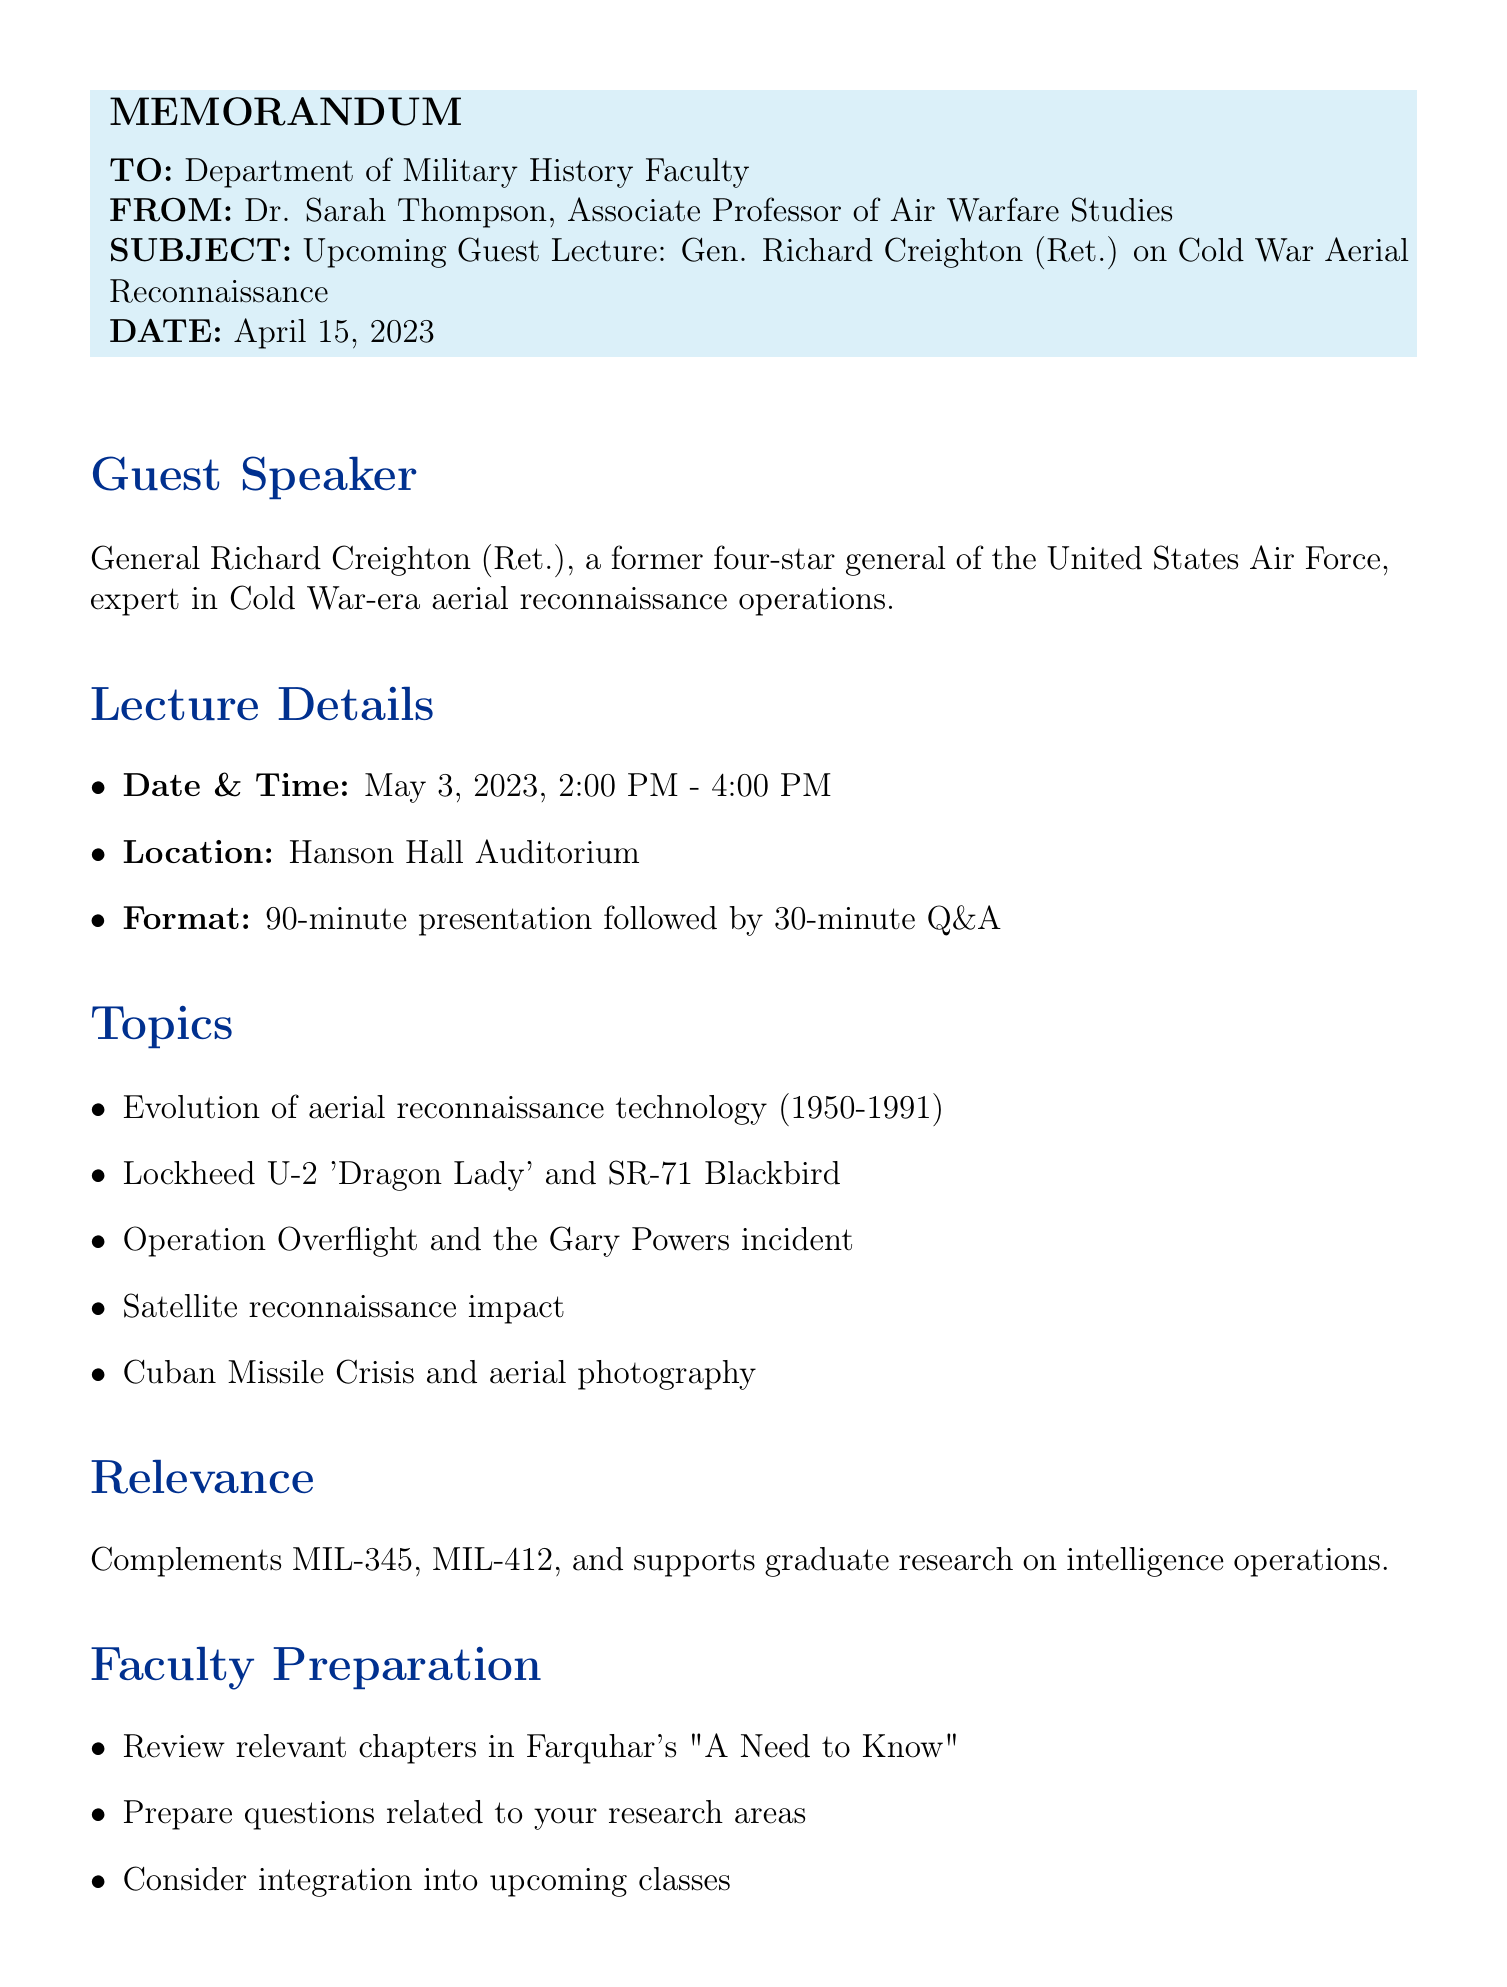What is the date of the guest lecture? The date of the guest lecture is explicitly mentioned in the document as May 3, 2023.
Answer: May 3, 2023 Who is the guest speaker? The document provides the name and rank of the guest speaker, General Richard Creighton, a retired Four-Star General.
Answer: General Richard Creighton What is the duration of the lecture? The document specifies that the lecture consists of a 90-minute presentation followed by a 30-minute Q&A, totaling 120 minutes.
Answer: 90 minutes What topic covers the role of U-2 and SR-71? The document lists the Lockheed U-2 'Dragon Lady' and SR-71 Blackbird under the topics to be discussed, highlighting their significance in aerial reconnaissance.
Answer: Lockheed U-2 'Dragon Lady' and SR-71 Blackbird How does the lecture complement coursework? The memo indicates that the lecture complements the Air Power in the Cold War course (MIL-345) and provides insights for Aerial Reconnaissance Tactics (MIL-412).
Answer: MIL-345 What is required for student attendance? The memo states that attendance is mandatory for all graduate students and seniors specializing in air warfare.
Answer: Mandatory What type of assignment is suggested for students? The suggested assignment for students is a 1000-word reflection paper on the lecture's key points and their historical significance.
Answer: 1000-word reflection paper What parking arrangements are mentioned? The document notes that there will be reserved spaces for General Creighton in Lot C for parking arrangements.
Answer: Reserved spaces in Lot C What is the media policy during the lecture? The memo states that no recording devices are allowed during the presentation, indicating strict media policy.
Answer: No recording devices 